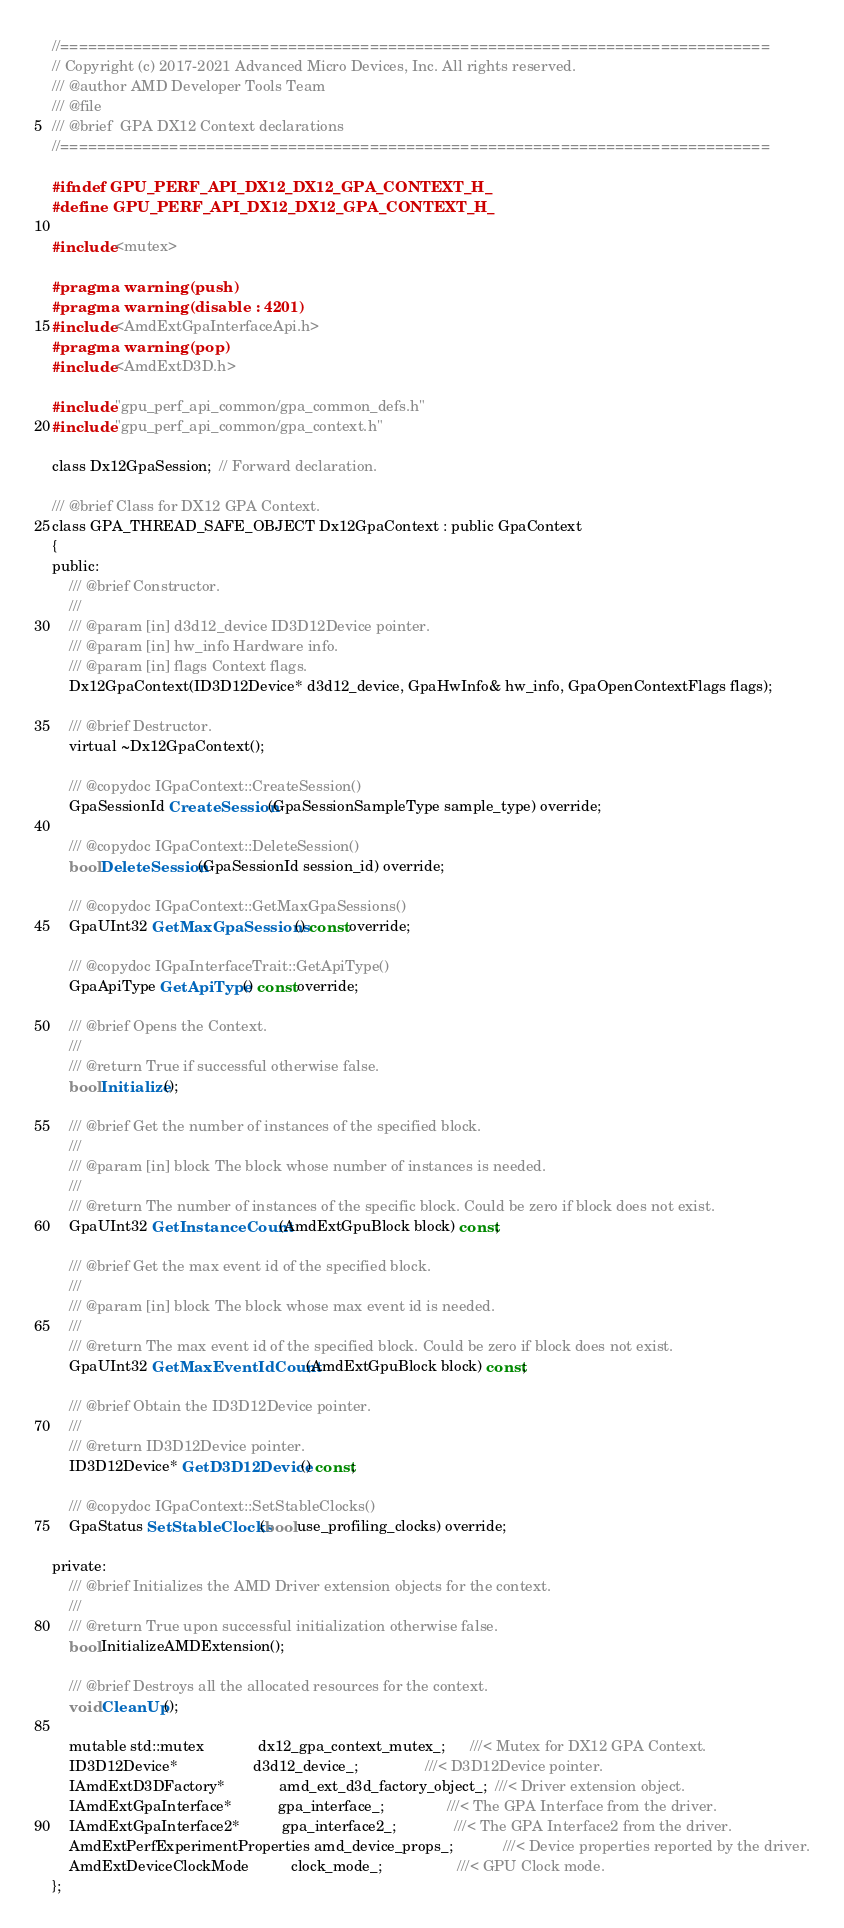Convert code to text. <code><loc_0><loc_0><loc_500><loc_500><_C_>//==============================================================================
// Copyright (c) 2017-2021 Advanced Micro Devices, Inc. All rights reserved.
/// @author AMD Developer Tools Team
/// @file
/// @brief  GPA DX12 Context declarations
//==============================================================================

#ifndef GPU_PERF_API_DX12_DX12_GPA_CONTEXT_H_
#define GPU_PERF_API_DX12_DX12_GPA_CONTEXT_H_

#include <mutex>

#pragma warning(push)
#pragma warning(disable : 4201)
#include <AmdExtGpaInterfaceApi.h>
#pragma warning(pop)
#include <AmdExtD3D.h>

#include "gpu_perf_api_common/gpa_common_defs.h"
#include "gpu_perf_api_common/gpa_context.h"

class Dx12GpaSession;  // Forward declaration.

/// @brief Class for DX12 GPA Context.
class GPA_THREAD_SAFE_OBJECT Dx12GpaContext : public GpaContext
{
public:
    /// @brief Constructor.
    ///
    /// @param [in] d3d12_device ID3D12Device pointer.
    /// @param [in] hw_info Hardware info.
    /// @param [in] flags Context flags.
    Dx12GpaContext(ID3D12Device* d3d12_device, GpaHwInfo& hw_info, GpaOpenContextFlags flags);

    /// @brief Destructor.
    virtual ~Dx12GpaContext();

    /// @copydoc IGpaContext::CreateSession()
    GpaSessionId CreateSession(GpaSessionSampleType sample_type) override;

    /// @copydoc IGpaContext::DeleteSession()
    bool DeleteSession(GpaSessionId session_id) override;

    /// @copydoc IGpaContext::GetMaxGpaSessions()
    GpaUInt32 GetMaxGpaSessions() const override;

    /// @copydoc IGpaInterfaceTrait::GetApiType()
    GpaApiType GetApiType() const override;

    /// @brief Opens the Context.
    ///
    /// @return True if successful otherwise false.
    bool Initialize();

    /// @brief Get the number of instances of the specified block.
    ///
    /// @param [in] block The block whose number of instances is needed.
    ///
    /// @return The number of instances of the specific block. Could be zero if block does not exist.
    GpaUInt32 GetInstanceCount(AmdExtGpuBlock block) const;

    /// @brief Get the max event id of the specified block.
    ///
    /// @param [in] block The block whose max event id is needed.
    ///
    /// @return The max event id of the specified block. Could be zero if block does not exist.
    GpaUInt32 GetMaxEventIdCount(AmdExtGpuBlock block) const;

    /// @brief Obtain the ID3D12Device pointer.
    ///
    /// @return ID3D12Device pointer.
    ID3D12Device* GetD3D12Device() const;

    /// @copydoc IGpaContext::SetStableClocks()
    GpaStatus SetStableClocks(bool use_profiling_clocks) override;

private:
    /// @brief Initializes the AMD Driver extension objects for the context.
    ///
    /// @return True upon successful initialization otherwise false.
    bool InitializeAMDExtension();

    /// @brief Destroys all the allocated resources for the context.
    void CleanUp();

    mutable std::mutex             dx12_gpa_context_mutex_;      ///< Mutex for DX12 GPA Context.
    ID3D12Device*                  d3d12_device_;                ///< D3D12Device pointer.
    IAmdExtD3DFactory*             amd_ext_d3d_factory_object_;  ///< Driver extension object.
    IAmdExtGpaInterface*           gpa_interface_;               ///< The GPA Interface from the driver.
    IAmdExtGpaInterface2*          gpa_interface2_;              ///< The GPA Interface2 from the driver.
    AmdExtPerfExperimentProperties amd_device_props_;            ///< Device properties reported by the driver.
    AmdExtDeviceClockMode          clock_mode_;                  ///< GPU Clock mode.
};
</code> 